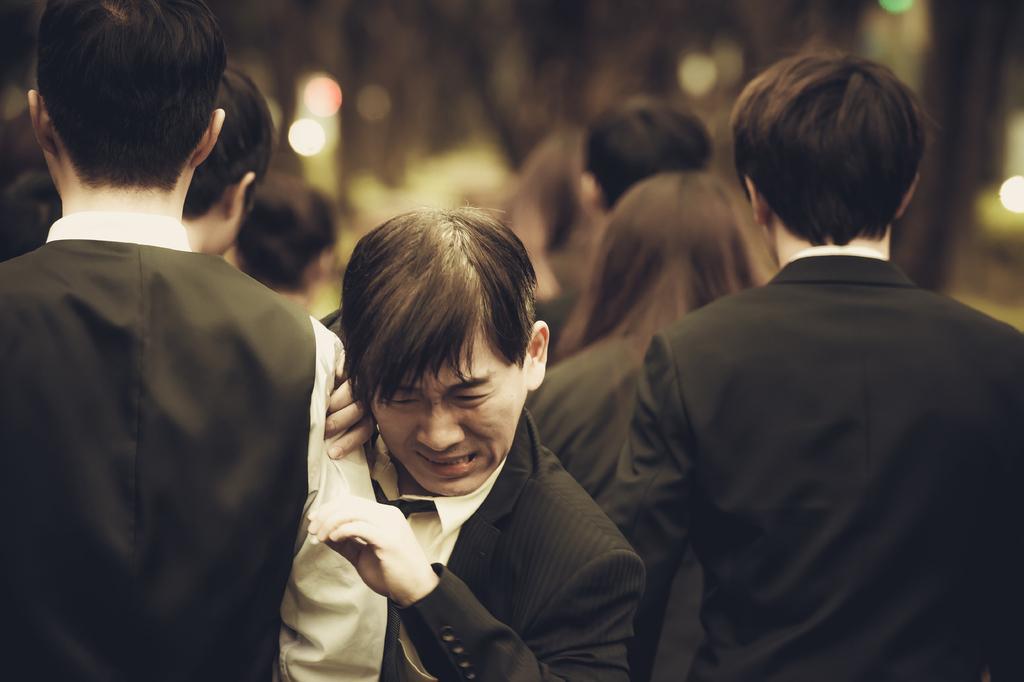Describe this image in one or two sentences. In the picture we can see all people are going and one man is pushing them and coming they all are in blazers and shirts and in the background we can see some trees which are not clearly visible. 